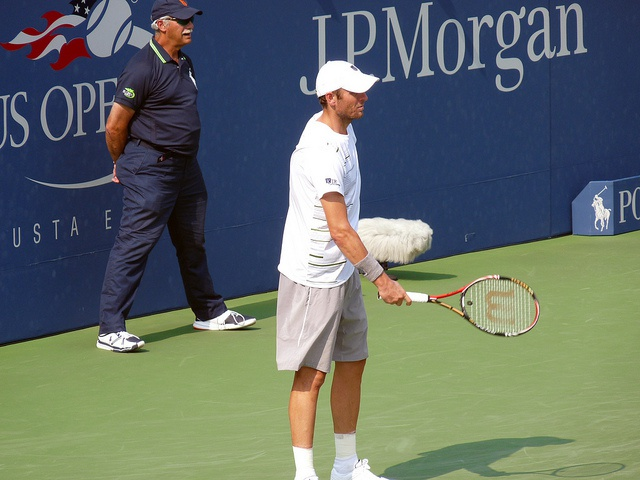Describe the objects in this image and their specific colors. I can see people in navy, white, gray, tan, and brown tones, people in navy, black, purple, and white tones, and tennis racket in navy, tan, beige, and ivory tones in this image. 